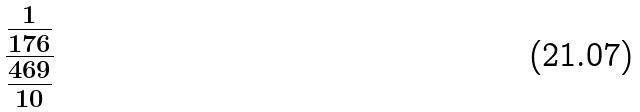Convert formula to latex. <formula><loc_0><loc_0><loc_500><loc_500>\frac { \frac { 1 } { 1 7 6 } } { \frac { 4 6 9 } { 1 0 } }</formula> 